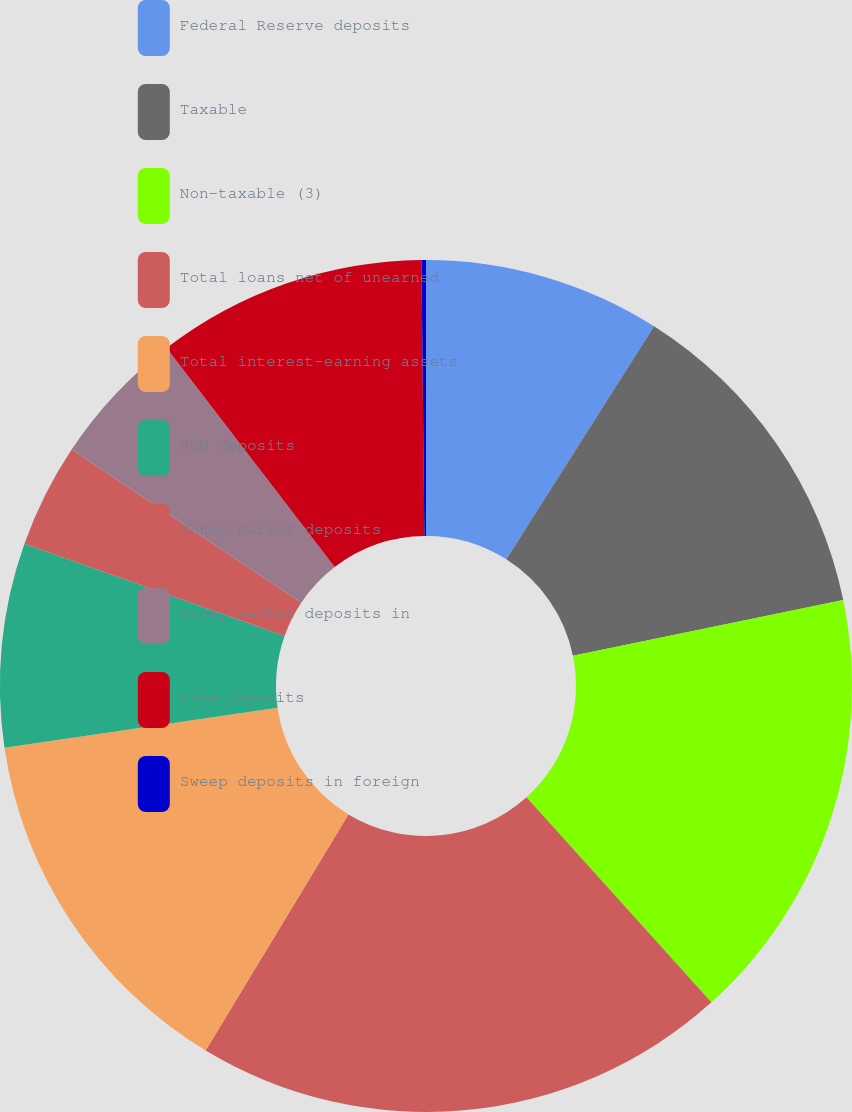<chart> <loc_0><loc_0><loc_500><loc_500><pie_chart><fcel>Federal Reserve deposits<fcel>Taxable<fcel>Non-taxable (3)<fcel>Total loans net of unearned<fcel>Total interest-earning assets<fcel>NOW deposits<fcel>Money market deposits<fcel>Money market deposits in<fcel>Time deposits<fcel>Sweep deposits in foreign<nl><fcel>8.99%<fcel>12.77%<fcel>16.55%<fcel>20.33%<fcel>14.03%<fcel>7.73%<fcel>3.95%<fcel>5.21%<fcel>10.25%<fcel>0.17%<nl></chart> 